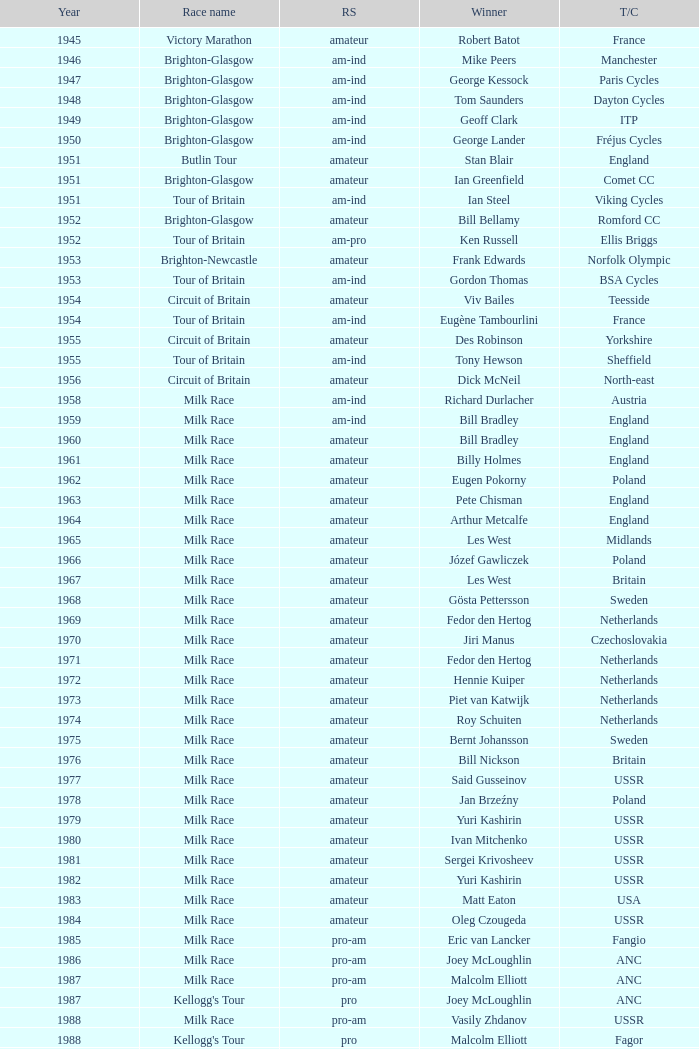What is the latest year when Phil Anderson won? 1993.0. 